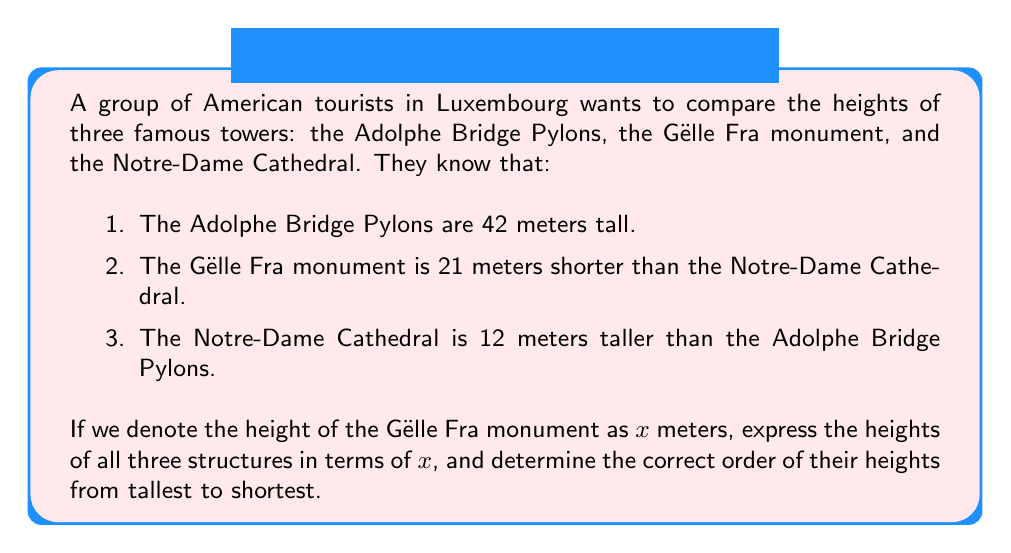Show me your answer to this math problem. Let's approach this step-by-step:

1. Let $x$ be the height of the Gëlle Fra monument in meters.

2. We know the Adolphe Bridge Pylons are 42 meters tall, so we can express this as:
   Adolphe Bridge Pylons = 42 m

3. The Notre-Dame Cathedral is 12 meters taller than the Adolphe Bridge Pylons:
   Notre-Dame Cathedral = 42 + 12 = 54 m

4. The Gëlle Fra monument is 21 meters shorter than the Notre-Dame Cathedral:
   $x = 54 - 21$
   $x = 33$ m

Now we have the heights of all three structures:
- Adolphe Bridge Pylons: 42 m
- Gëlle Fra monument: 33 m
- Notre-Dame Cathedral: 54 m

To order them from tallest to shortest, we compare these values:

$54 > 42 > 33$

Therefore, the order from tallest to shortest is:
Notre-Dame Cathedral > Adolphe Bridge Pylons > Gëlle Fra monument
Answer: Notre-Dame Cathedral (54 m) > Adolphe Bridge Pylons (42 m) > Gëlle Fra monument (33 m) 